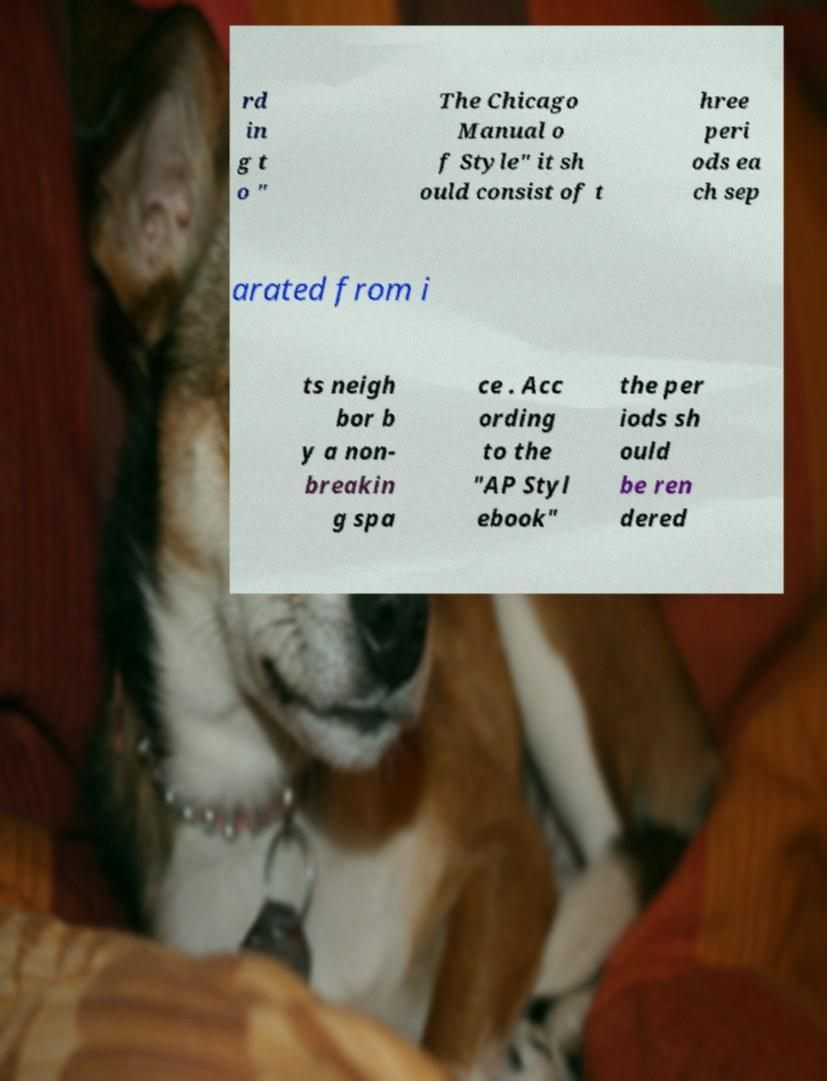Can you accurately transcribe the text from the provided image for me? rd in g t o " The Chicago Manual o f Style" it sh ould consist of t hree peri ods ea ch sep arated from i ts neigh bor b y a non- breakin g spa ce . Acc ording to the "AP Styl ebook" the per iods sh ould be ren dered 